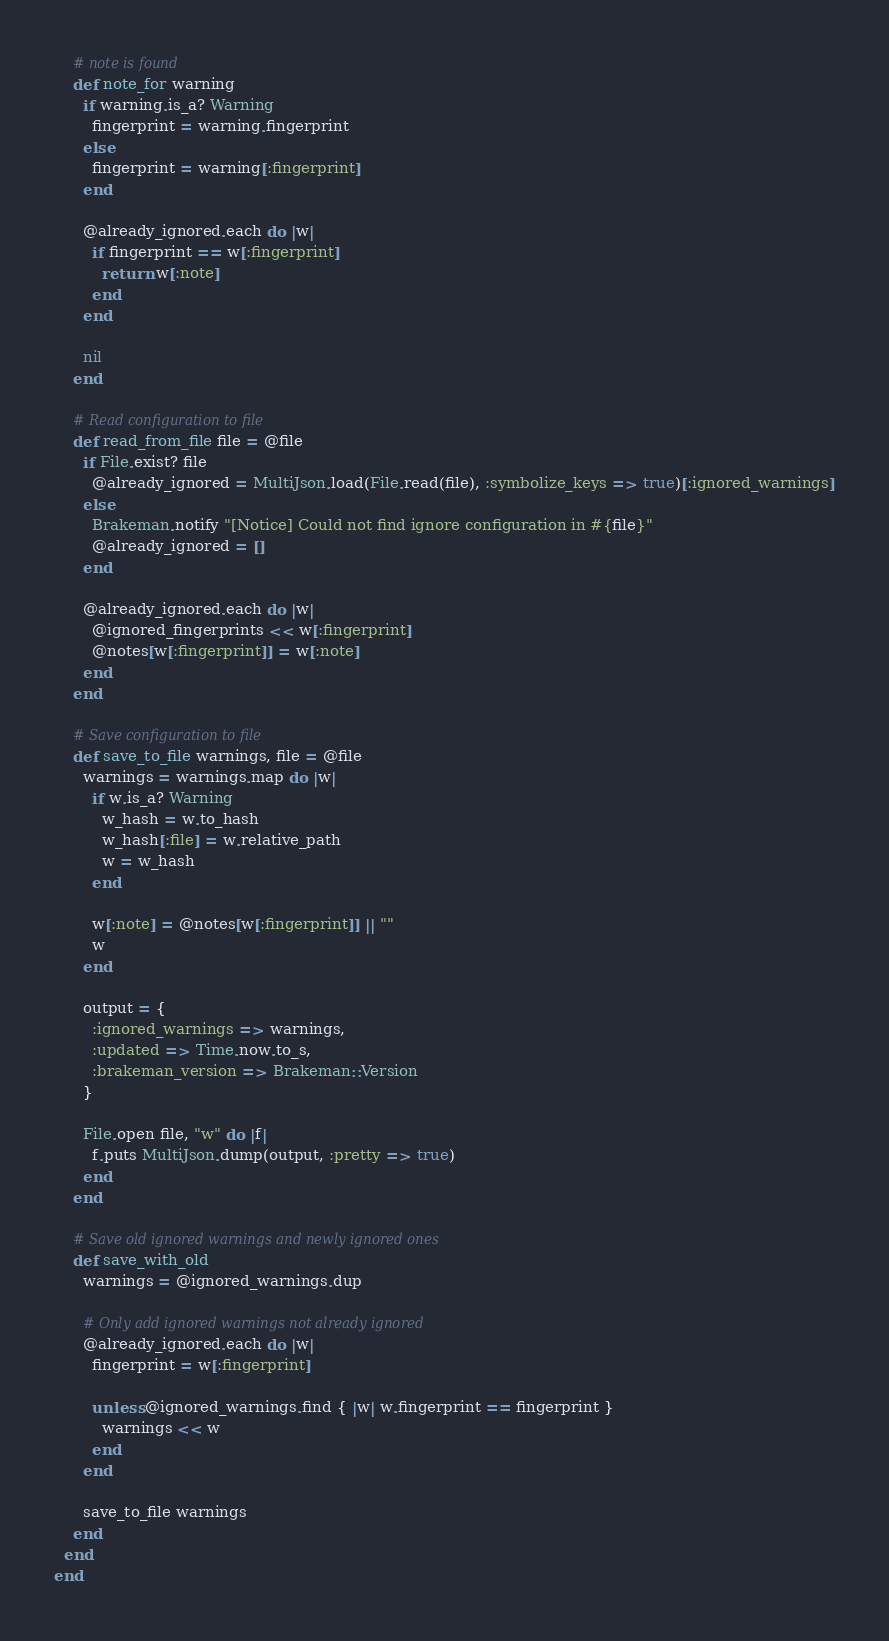Convert code to text. <code><loc_0><loc_0><loc_500><loc_500><_Ruby_>    # note is found
    def note_for warning
      if warning.is_a? Warning
        fingerprint = warning.fingerprint
      else
        fingerprint = warning[:fingerprint]
      end

      @already_ignored.each do |w|
        if fingerprint == w[:fingerprint]
          return w[:note]
        end
      end

      nil
    end

    # Read configuration to file
    def read_from_file file = @file
      if File.exist? file
        @already_ignored = MultiJson.load(File.read(file), :symbolize_keys => true)[:ignored_warnings]
      else
        Brakeman.notify "[Notice] Could not find ignore configuration in #{file}"
        @already_ignored = []
      end

      @already_ignored.each do |w|
        @ignored_fingerprints << w[:fingerprint]
        @notes[w[:fingerprint]] = w[:note]
      end
    end

    # Save configuration to file
    def save_to_file warnings, file = @file
      warnings = warnings.map do |w|
        if w.is_a? Warning
          w_hash = w.to_hash
          w_hash[:file] = w.relative_path
          w = w_hash
        end

        w[:note] = @notes[w[:fingerprint]] || ""
        w
      end

      output = {
        :ignored_warnings => warnings,
        :updated => Time.now.to_s,
        :brakeman_version => Brakeman::Version
      }

      File.open file, "w" do |f|
        f.puts MultiJson.dump(output, :pretty => true)
      end
    end

    # Save old ignored warnings and newly ignored ones
    def save_with_old
      warnings = @ignored_warnings.dup

      # Only add ignored warnings not already ignored
      @already_ignored.each do |w|
        fingerprint = w[:fingerprint]

        unless @ignored_warnings.find { |w| w.fingerprint == fingerprint }
          warnings << w
        end
      end

      save_to_file warnings
    end
  end
end
</code> 